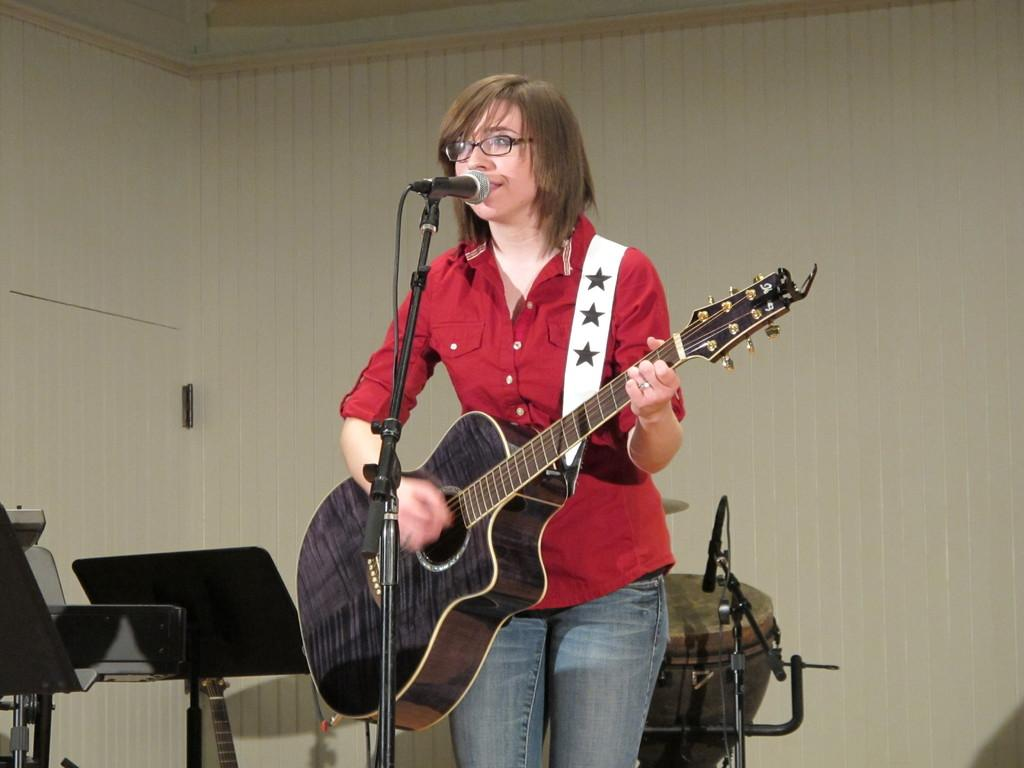What is the main subject of the image? The main subject of the image is a woman. What is the woman doing in the image? The woman is standing, playing a guitar, and singing into a microphone. What can be seen in the background of the image? In the background of the image, there are chairs, a tabla, a microphone, and a wall. What type of pancake is the woman flipping in the image? There is no pancake present in the image; the woman is playing a guitar and singing into a microphone. How does the woman maintain her balance while playing the guitar and singing? The image does not provide information about the woman's balance, but she appears to be standing and playing the guitar without any visible difficulty. 